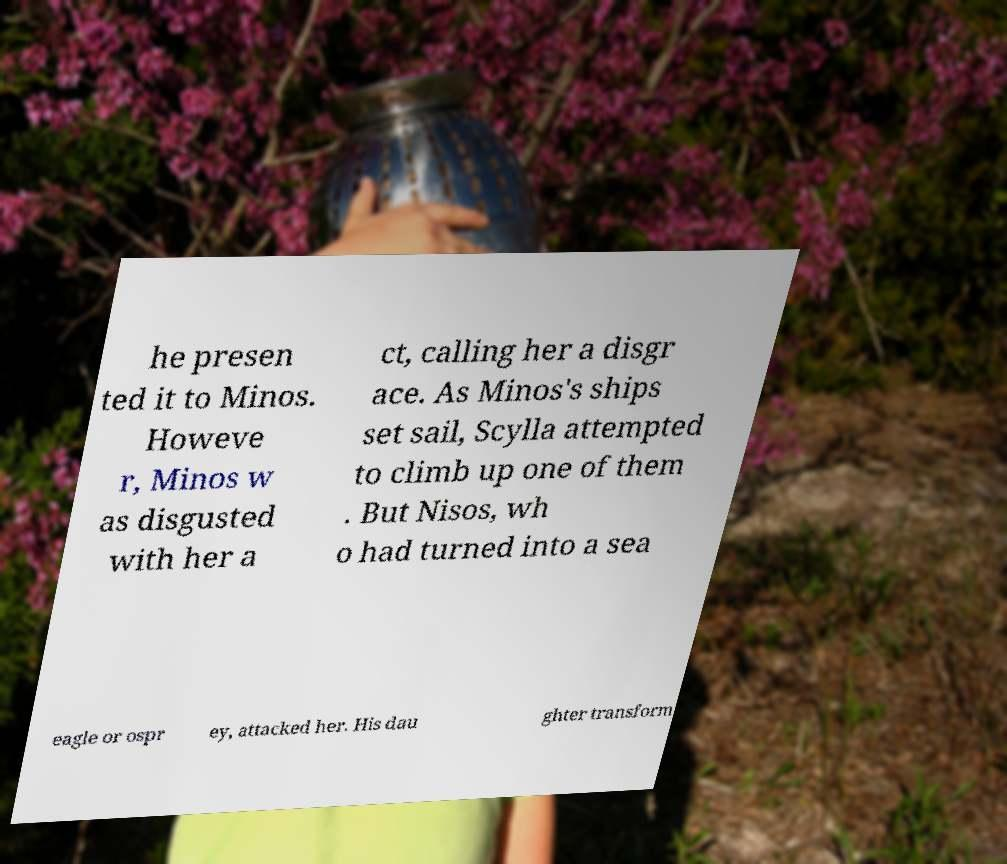What messages or text are displayed in this image? I need them in a readable, typed format. he presen ted it to Minos. Howeve r, Minos w as disgusted with her a ct, calling her a disgr ace. As Minos's ships set sail, Scylla attempted to climb up one of them . But Nisos, wh o had turned into a sea eagle or ospr ey, attacked her. His dau ghter transform 